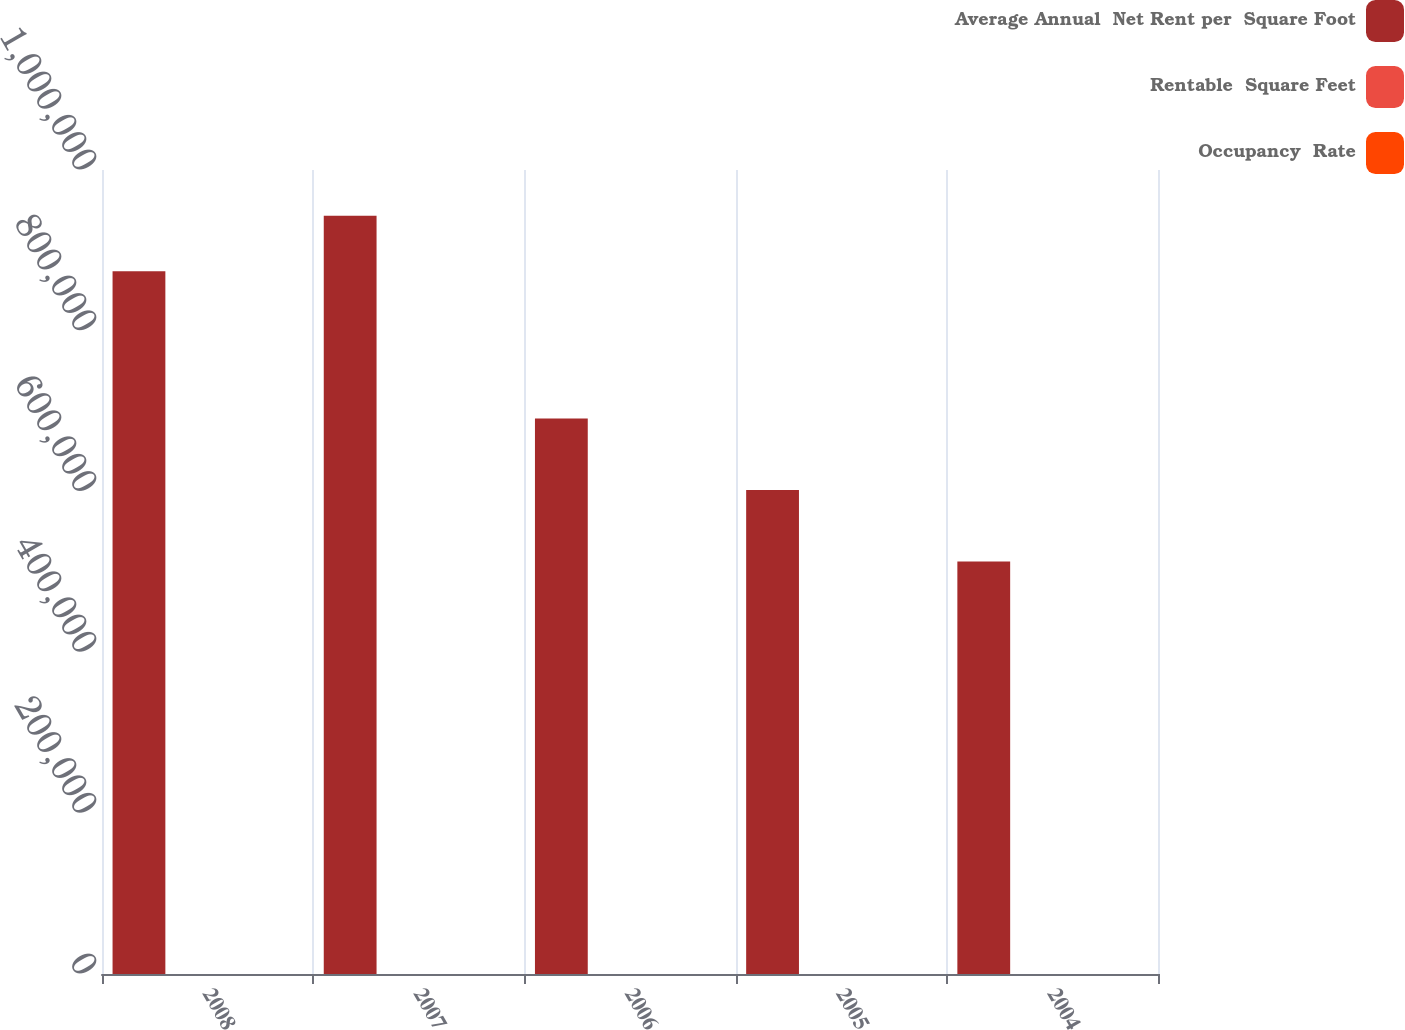Convert chart. <chart><loc_0><loc_0><loc_500><loc_500><stacked_bar_chart><ecel><fcel>2008<fcel>2007<fcel>2006<fcel>2005<fcel>2004<nl><fcel>Average Annual  Net Rent per  Square Foot<fcel>874000<fcel>943000<fcel>691000<fcel>602000<fcel>513000<nl><fcel>Rentable  Square Feet<fcel>90.4<fcel>86.8<fcel>83.6<fcel>90.9<fcel>88.7<nl><fcel>Occupancy  Rate<fcel>97.18<fcel>89.86<fcel>83.53<fcel>81.94<fcel>72.81<nl></chart> 